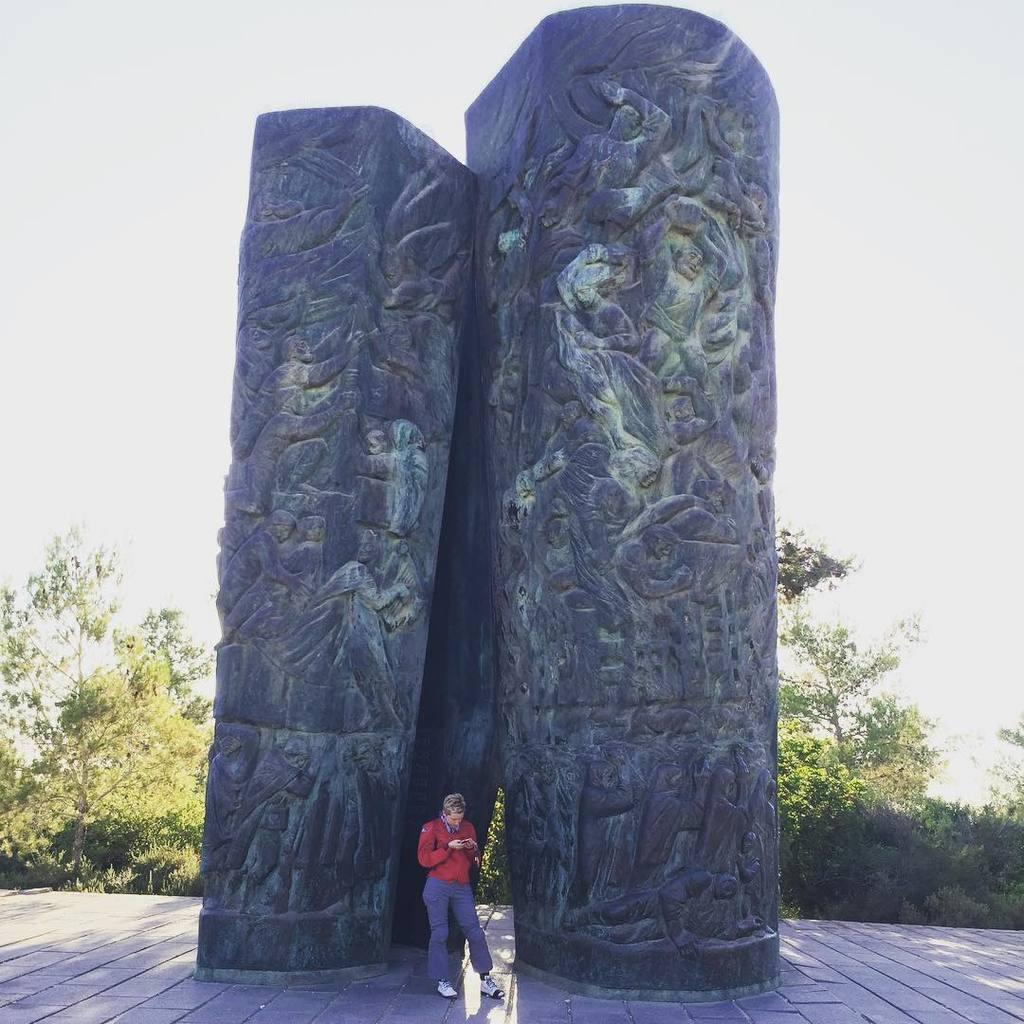Where was the image taken? The image was clicked outside. What is the main subject of the image? There is a person standing in the center of the image. What is the person's position in relation to the ground? The person is standing on the ground. What can be seen in the background of the image? The sky, trees, and plants are visible in the background. Are there any objects present in the image? Yes, there are some objects in the image. What type of grape is being traded by the government in the image? There is no mention of grapes, trade, or government in the image. The image features a person standing outside with a background of sky, trees, and plants. 